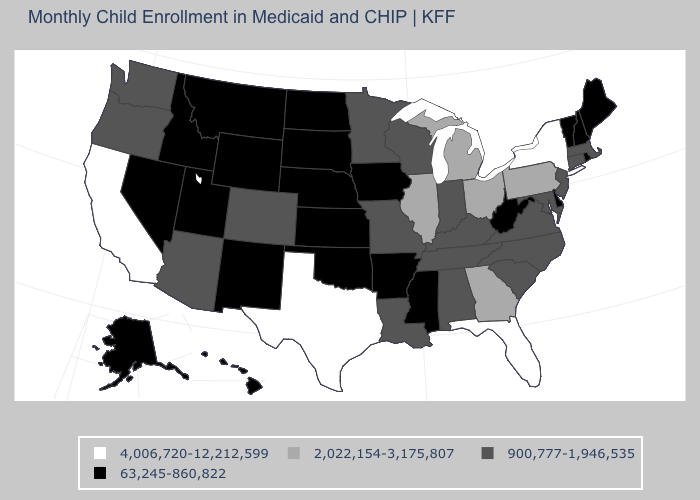What is the value of West Virginia?
Be succinct. 63,245-860,822. Which states have the highest value in the USA?
Be succinct. California, Florida, New York, Texas. What is the value of Nevada?
Write a very short answer. 63,245-860,822. What is the value of New Mexico?
Answer briefly. 63,245-860,822. What is the value of Nebraska?
Be succinct. 63,245-860,822. Name the states that have a value in the range 900,777-1,946,535?
Be succinct. Alabama, Arizona, Colorado, Connecticut, Indiana, Kentucky, Louisiana, Maryland, Massachusetts, Minnesota, Missouri, New Jersey, North Carolina, Oregon, South Carolina, Tennessee, Virginia, Washington, Wisconsin. Does Texas have the highest value in the USA?
Write a very short answer. Yes. Among the states that border Idaho , which have the highest value?
Be succinct. Oregon, Washington. Which states have the lowest value in the Northeast?
Write a very short answer. Maine, New Hampshire, Rhode Island, Vermont. What is the lowest value in the South?
Write a very short answer. 63,245-860,822. Does Oregon have the lowest value in the USA?
Keep it brief. No. How many symbols are there in the legend?
Be succinct. 4. Name the states that have a value in the range 900,777-1,946,535?
Concise answer only. Alabama, Arizona, Colorado, Connecticut, Indiana, Kentucky, Louisiana, Maryland, Massachusetts, Minnesota, Missouri, New Jersey, North Carolina, Oregon, South Carolina, Tennessee, Virginia, Washington, Wisconsin. What is the lowest value in states that border Missouri?
Be succinct. 63,245-860,822. Name the states that have a value in the range 63,245-860,822?
Keep it brief. Alaska, Arkansas, Delaware, Hawaii, Idaho, Iowa, Kansas, Maine, Mississippi, Montana, Nebraska, Nevada, New Hampshire, New Mexico, North Dakota, Oklahoma, Rhode Island, South Dakota, Utah, Vermont, West Virginia, Wyoming. 